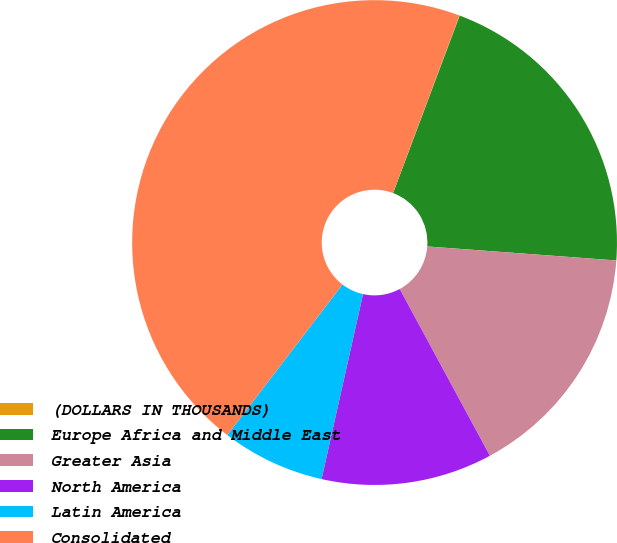<chart> <loc_0><loc_0><loc_500><loc_500><pie_chart><fcel>(DOLLARS IN THOUSANDS)<fcel>Europe Africa and Middle East<fcel>Greater Asia<fcel>North America<fcel>Latin America<fcel>Consolidated<nl><fcel>0.03%<fcel>20.46%<fcel>15.93%<fcel>11.4%<fcel>6.88%<fcel>45.29%<nl></chart> 